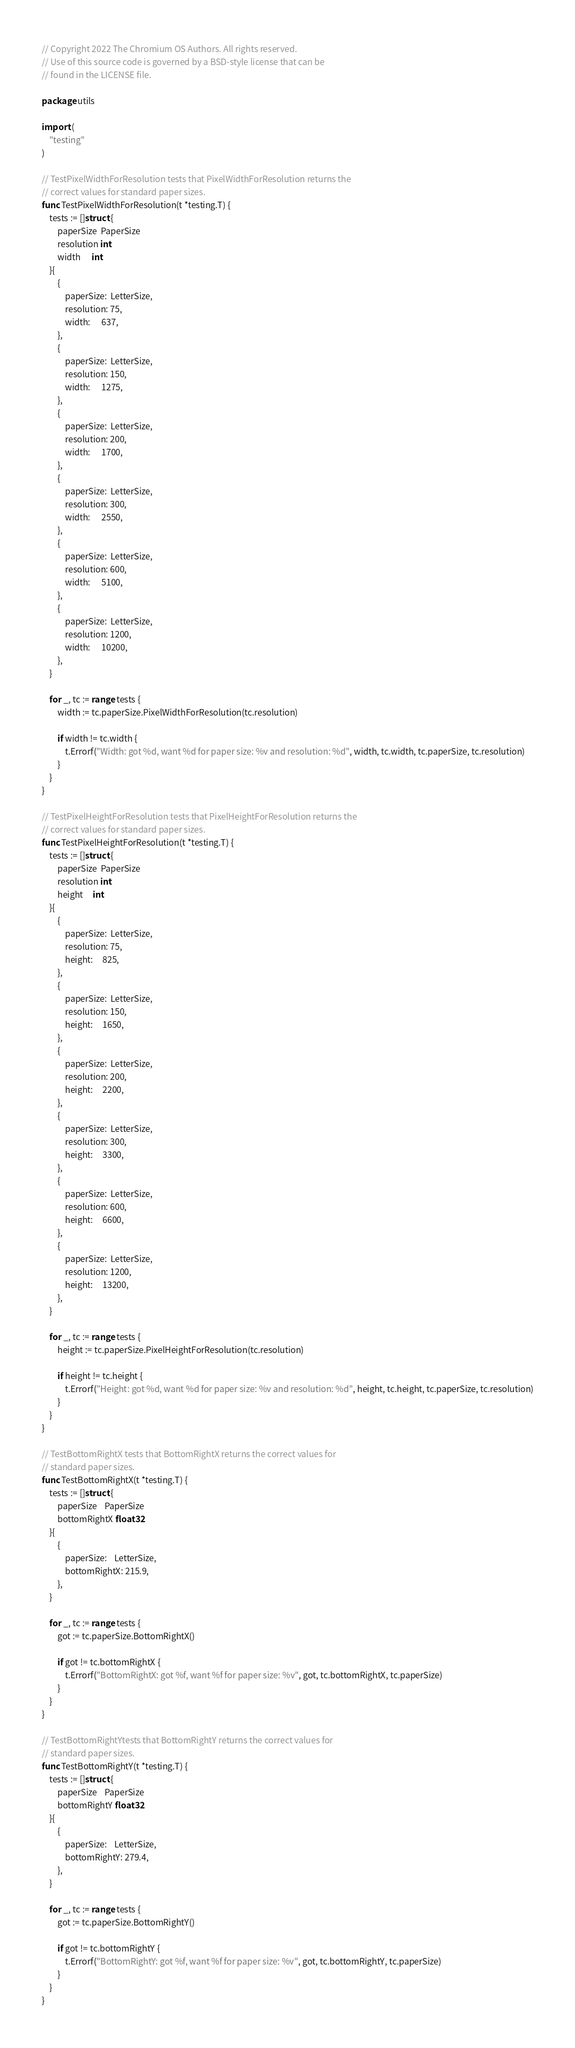<code> <loc_0><loc_0><loc_500><loc_500><_Go_>// Copyright 2022 The Chromium OS Authors. All rights reserved.
// Use of this source code is governed by a BSD-style license that can be
// found in the LICENSE file.

package utils

import (
	"testing"
)

// TestPixelWidthForResolution tests that PixelWidthForResolution returns the
// correct values for standard paper sizes.
func TestPixelWidthForResolution(t *testing.T) {
	tests := []struct {
		paperSize  PaperSize
		resolution int
		width      int
	}{
		{
			paperSize:  LetterSize,
			resolution: 75,
			width:      637,
		},
		{
			paperSize:  LetterSize,
			resolution: 150,
			width:      1275,
		},
		{
			paperSize:  LetterSize,
			resolution: 200,
			width:      1700,
		},
		{
			paperSize:  LetterSize,
			resolution: 300,
			width:      2550,
		},
		{
			paperSize:  LetterSize,
			resolution: 600,
			width:      5100,
		},
		{
			paperSize:  LetterSize,
			resolution: 1200,
			width:      10200,
		},
	}

	for _, tc := range tests {
		width := tc.paperSize.PixelWidthForResolution(tc.resolution)

		if width != tc.width {
			t.Errorf("Width: got %d, want %d for paper size: %v and resolution: %d", width, tc.width, tc.paperSize, tc.resolution)
		}
	}
}

// TestPixelHeightForResolution tests that PixelHeightForResolution returns the
// correct values for standard paper sizes.
func TestPixelHeightForResolution(t *testing.T) {
	tests := []struct {
		paperSize  PaperSize
		resolution int
		height     int
	}{
		{
			paperSize:  LetterSize,
			resolution: 75,
			height:     825,
		},
		{
			paperSize:  LetterSize,
			resolution: 150,
			height:     1650,
		},
		{
			paperSize:  LetterSize,
			resolution: 200,
			height:     2200,
		},
		{
			paperSize:  LetterSize,
			resolution: 300,
			height:     3300,
		},
		{
			paperSize:  LetterSize,
			resolution: 600,
			height:     6600,
		},
		{
			paperSize:  LetterSize,
			resolution: 1200,
			height:     13200,
		},
	}

	for _, tc := range tests {
		height := tc.paperSize.PixelHeightForResolution(tc.resolution)

		if height != tc.height {
			t.Errorf("Height: got %d, want %d for paper size: %v and resolution: %d", height, tc.height, tc.paperSize, tc.resolution)
		}
	}
}

// TestBottomRightX tests that BottomRightX returns the correct values for
// standard paper sizes.
func TestBottomRightX(t *testing.T) {
	tests := []struct {
		paperSize    PaperSize
		bottomRightX float32
	}{
		{
			paperSize:    LetterSize,
			bottomRightX: 215.9,
		},
	}

	for _, tc := range tests {
		got := tc.paperSize.BottomRightX()

		if got != tc.bottomRightX {
			t.Errorf("BottomRightX: got %f, want %f for paper size: %v", got, tc.bottomRightX, tc.paperSize)
		}
	}
}

// TestBottomRightYtests that BottomRightY returns the correct values for
// standard paper sizes.
func TestBottomRightY(t *testing.T) {
	tests := []struct {
		paperSize    PaperSize
		bottomRightY float32
	}{
		{
			paperSize:    LetterSize,
			bottomRightY: 279.4,
		},
	}

	for _, tc := range tests {
		got := tc.paperSize.BottomRightY()

		if got != tc.bottomRightY {
			t.Errorf("BottomRightY: got %f, want %f for paper size: %v", got, tc.bottomRightY, tc.paperSize)
		}
	}
}
</code> 